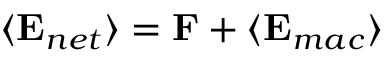Convert formula to latex. <formula><loc_0><loc_0><loc_500><loc_500>\langle { E } _ { n e t } \rangle = { F } + \langle { E } _ { m a c } \rangle</formula> 